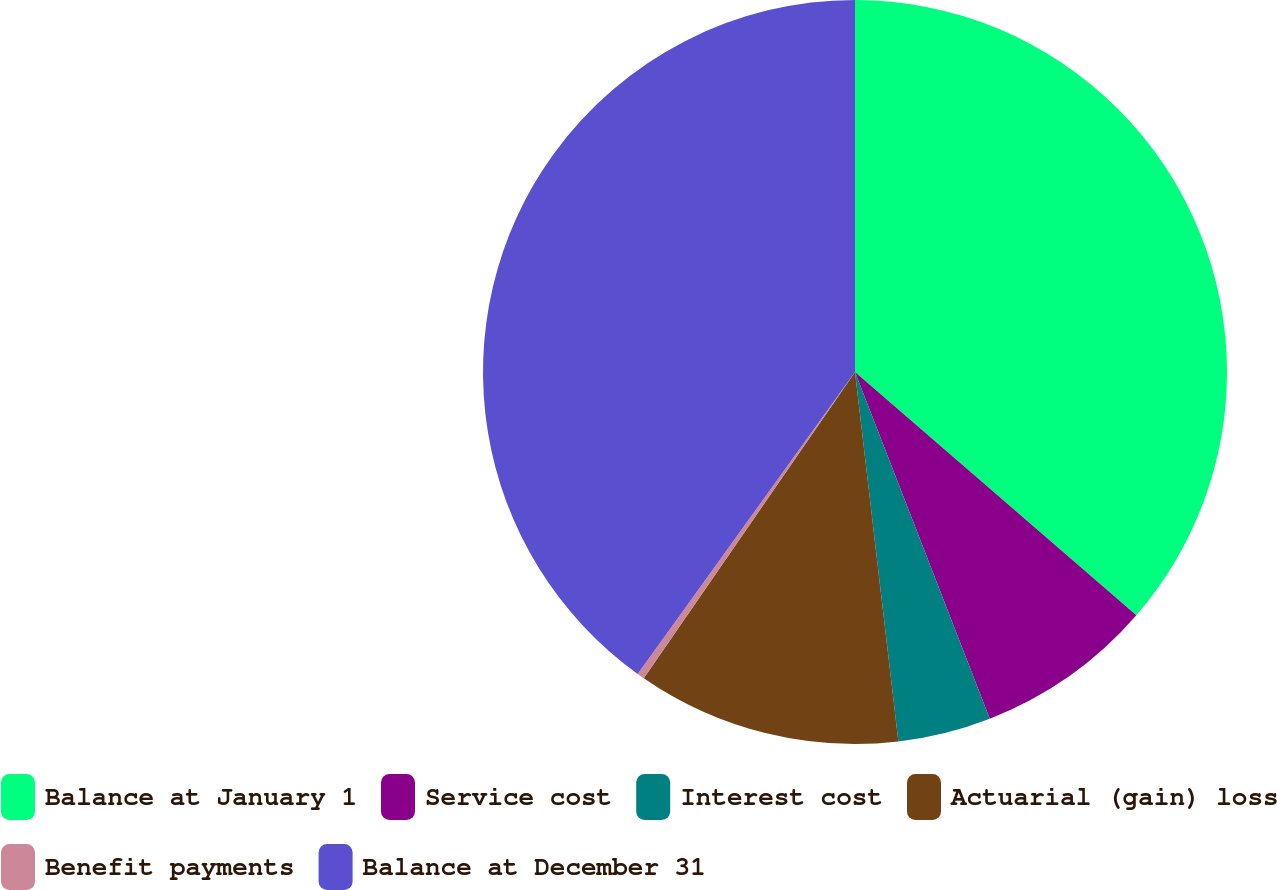Convert chart. <chart><loc_0><loc_0><loc_500><loc_500><pie_chart><fcel>Balance at January 1<fcel>Service cost<fcel>Interest cost<fcel>Actuarial (gain) loss<fcel>Benefit payments<fcel>Balance at December 31<nl><fcel>36.35%<fcel>7.75%<fcel>4.04%<fcel>11.47%<fcel>0.32%<fcel>40.07%<nl></chart> 